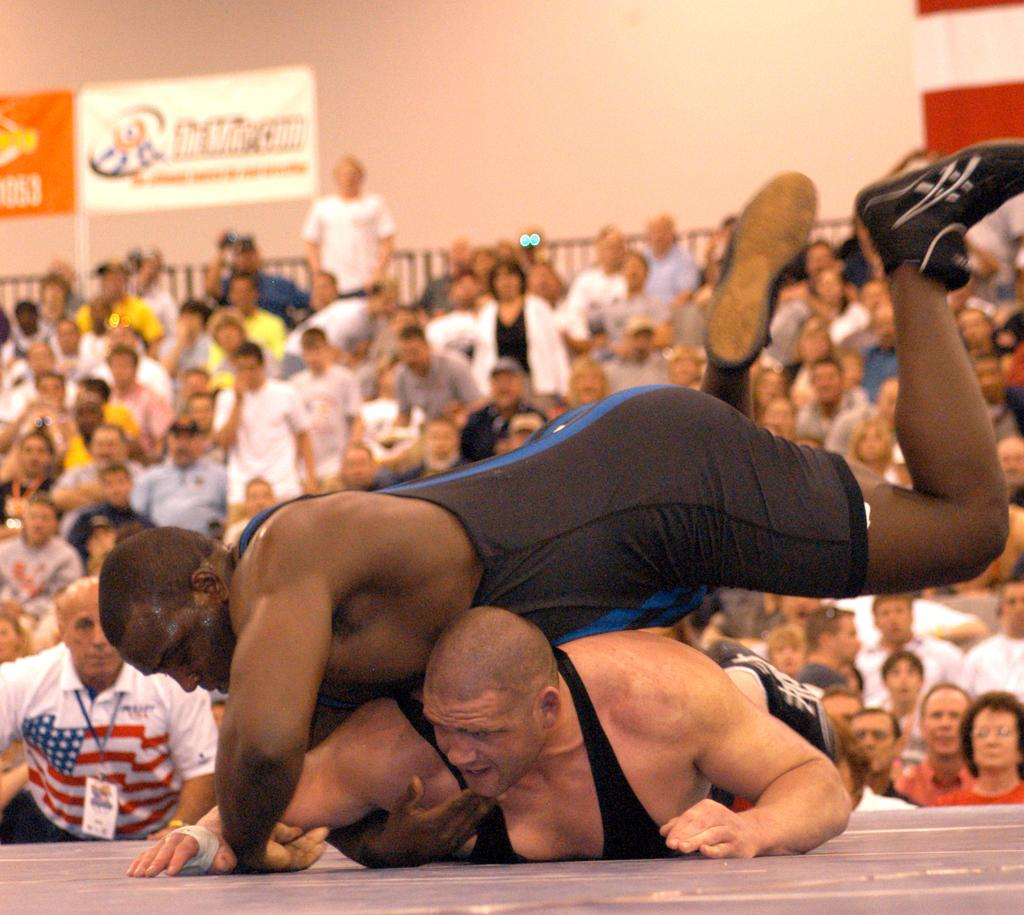How many people are in the image? There are two men in the image. What are the two men doing in the image? The two men appear to be fighting. Can you describe the setting of the image? There are people in the background of the image, and there is a wall visible in the background. What type of brush is being used by one of the men in the image? There is no brush present in the image; the two men appear to be fighting without any visible objects. 